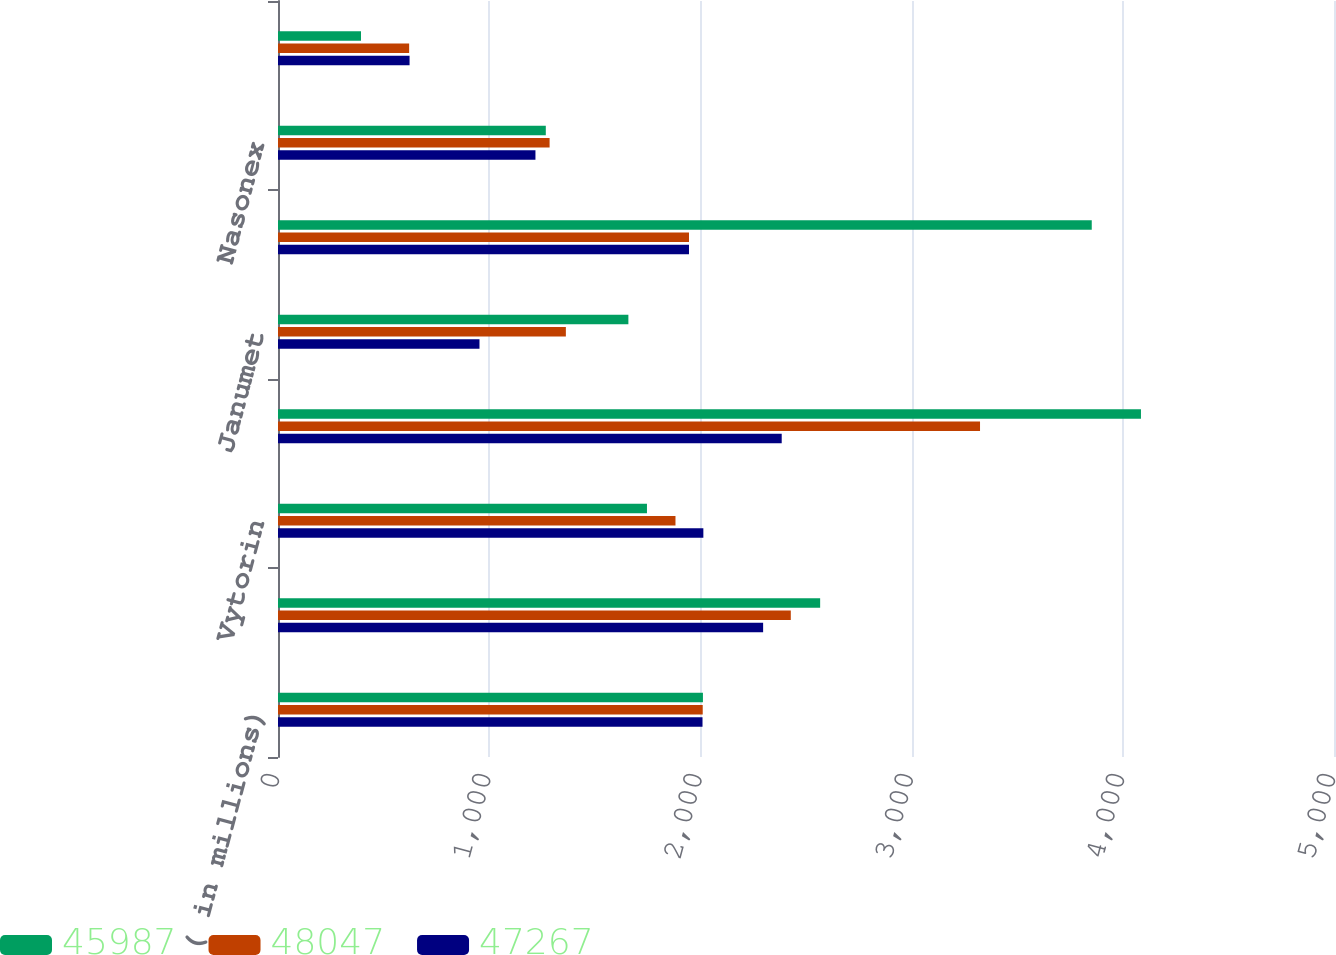Convert chart to OTSL. <chart><loc_0><loc_0><loc_500><loc_500><stacked_bar_chart><ecel><fcel>( in millions)<fcel>Zetia<fcel>Vytorin<fcel>Januvia<fcel>Janumet<fcel>Singulair<fcel>Nasonex<fcel>Clarinex<nl><fcel>45987<fcel>2012<fcel>2567<fcel>1747<fcel>4086<fcel>1659<fcel>3853<fcel>1268<fcel>393<nl><fcel>48047<fcel>2011<fcel>2428<fcel>1882<fcel>3324<fcel>1363<fcel>1946<fcel>1286<fcel>621<nl><fcel>47267<fcel>2010<fcel>2297<fcel>2014<fcel>2385<fcel>954<fcel>1946<fcel>1219<fcel>623<nl></chart> 